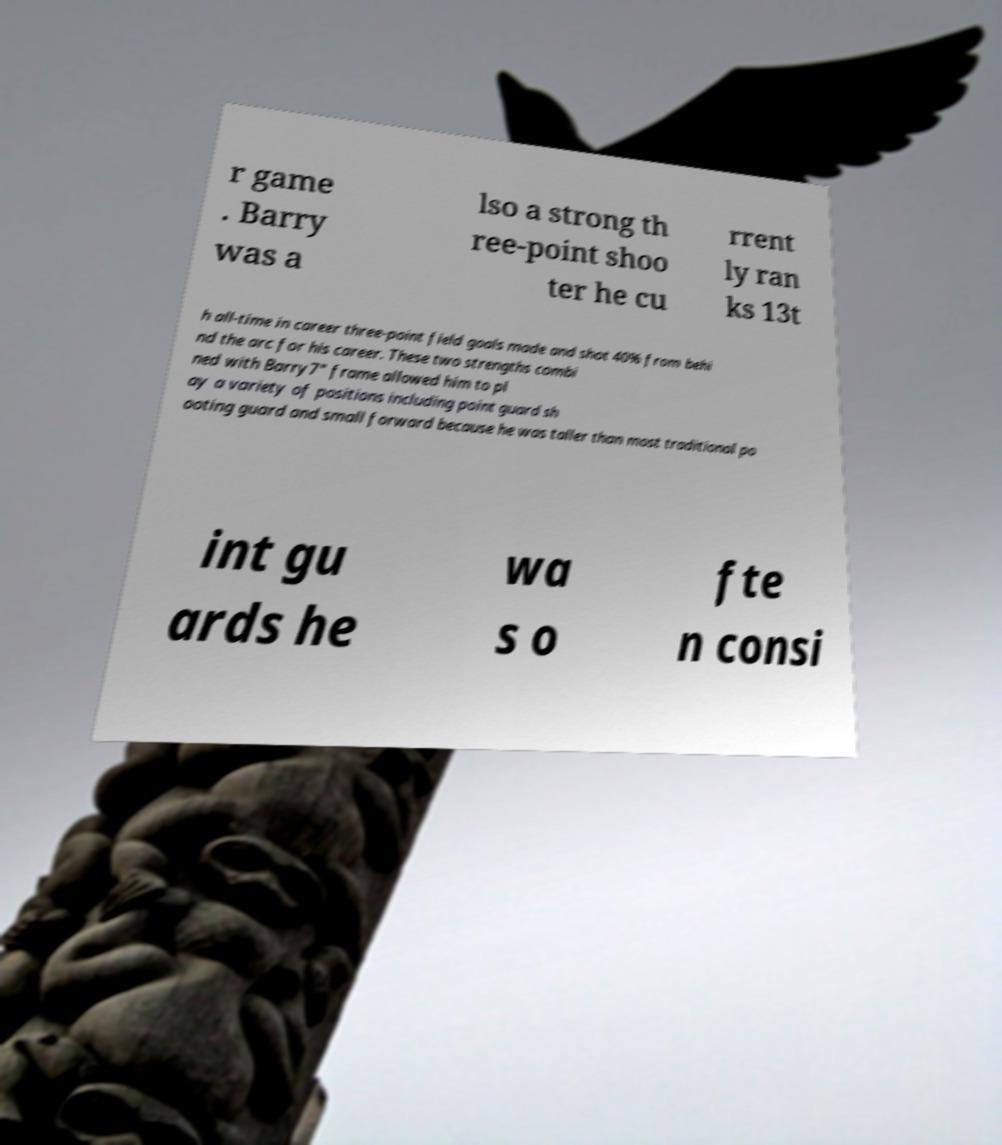There's text embedded in this image that I need extracted. Can you transcribe it verbatim? r game . Barry was a lso a strong th ree-point shoo ter he cu rrent ly ran ks 13t h all-time in career three-point field goals made and shot 40% from behi nd the arc for his career. These two strengths combi ned with Barry7" frame allowed him to pl ay a variety of positions including point guard sh ooting guard and small forward because he was taller than most traditional po int gu ards he wa s o fte n consi 